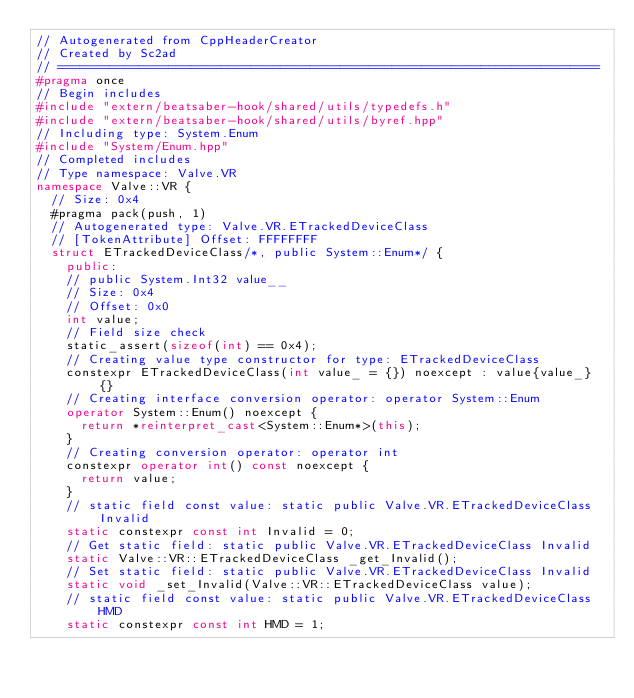<code> <loc_0><loc_0><loc_500><loc_500><_C++_>// Autogenerated from CppHeaderCreator
// Created by Sc2ad
// =========================================================================
#pragma once
// Begin includes
#include "extern/beatsaber-hook/shared/utils/typedefs.h"
#include "extern/beatsaber-hook/shared/utils/byref.hpp"
// Including type: System.Enum
#include "System/Enum.hpp"
// Completed includes
// Type namespace: Valve.VR
namespace Valve::VR {
  // Size: 0x4
  #pragma pack(push, 1)
  // Autogenerated type: Valve.VR.ETrackedDeviceClass
  // [TokenAttribute] Offset: FFFFFFFF
  struct ETrackedDeviceClass/*, public System::Enum*/ {
    public:
    // public System.Int32 value__
    // Size: 0x4
    // Offset: 0x0
    int value;
    // Field size check
    static_assert(sizeof(int) == 0x4);
    // Creating value type constructor for type: ETrackedDeviceClass
    constexpr ETrackedDeviceClass(int value_ = {}) noexcept : value{value_} {}
    // Creating interface conversion operator: operator System::Enum
    operator System::Enum() noexcept {
      return *reinterpret_cast<System::Enum*>(this);
    }
    // Creating conversion operator: operator int
    constexpr operator int() const noexcept {
      return value;
    }
    // static field const value: static public Valve.VR.ETrackedDeviceClass Invalid
    static constexpr const int Invalid = 0;
    // Get static field: static public Valve.VR.ETrackedDeviceClass Invalid
    static Valve::VR::ETrackedDeviceClass _get_Invalid();
    // Set static field: static public Valve.VR.ETrackedDeviceClass Invalid
    static void _set_Invalid(Valve::VR::ETrackedDeviceClass value);
    // static field const value: static public Valve.VR.ETrackedDeviceClass HMD
    static constexpr const int HMD = 1;</code> 